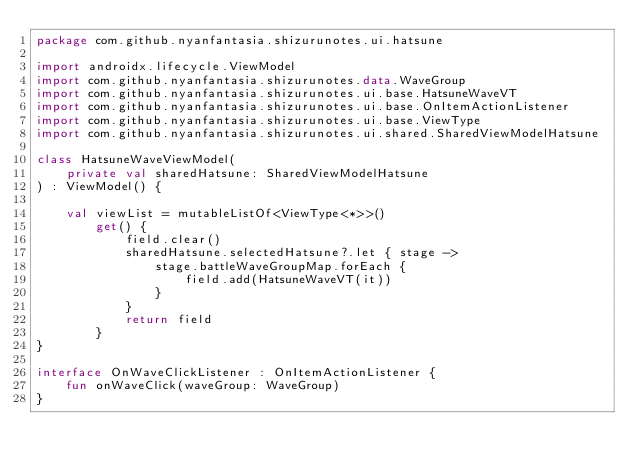Convert code to text. <code><loc_0><loc_0><loc_500><loc_500><_Kotlin_>package com.github.nyanfantasia.shizurunotes.ui.hatsune

import androidx.lifecycle.ViewModel
import com.github.nyanfantasia.shizurunotes.data.WaveGroup
import com.github.nyanfantasia.shizurunotes.ui.base.HatsuneWaveVT
import com.github.nyanfantasia.shizurunotes.ui.base.OnItemActionListener
import com.github.nyanfantasia.shizurunotes.ui.base.ViewType
import com.github.nyanfantasia.shizurunotes.ui.shared.SharedViewModelHatsune

class HatsuneWaveViewModel(
    private val sharedHatsune: SharedViewModelHatsune
) : ViewModel() {

    val viewList = mutableListOf<ViewType<*>>()
        get() {
            field.clear()
            sharedHatsune.selectedHatsune?.let { stage ->
                stage.battleWaveGroupMap.forEach {
                    field.add(HatsuneWaveVT(it))
                }
            }
            return field
        }
}

interface OnWaveClickListener : OnItemActionListener {
    fun onWaveClick(waveGroup: WaveGroup)
}</code> 